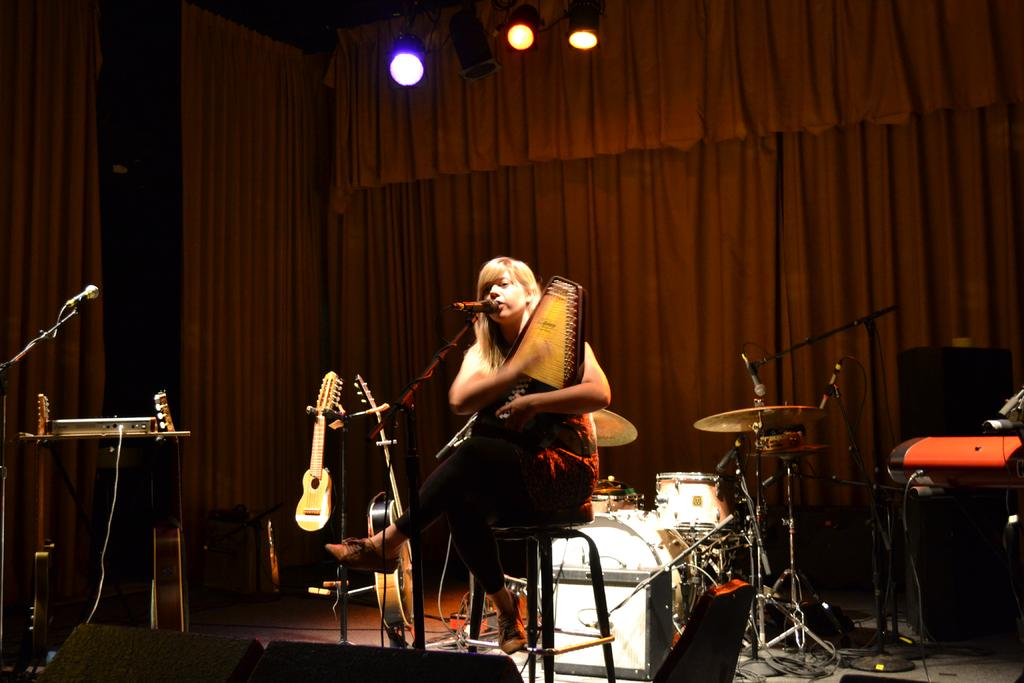What is the person in the image doing? The person is sitting in front of a mic and holding a musical instrument. What can be seen behind the person in the image? There is a curtain and lights visible in the background of the image. What type of pleasure can be seen being derived from the thunder in the image? There is no thunder present in the image, and therefore no pleasure can be derived from it. 